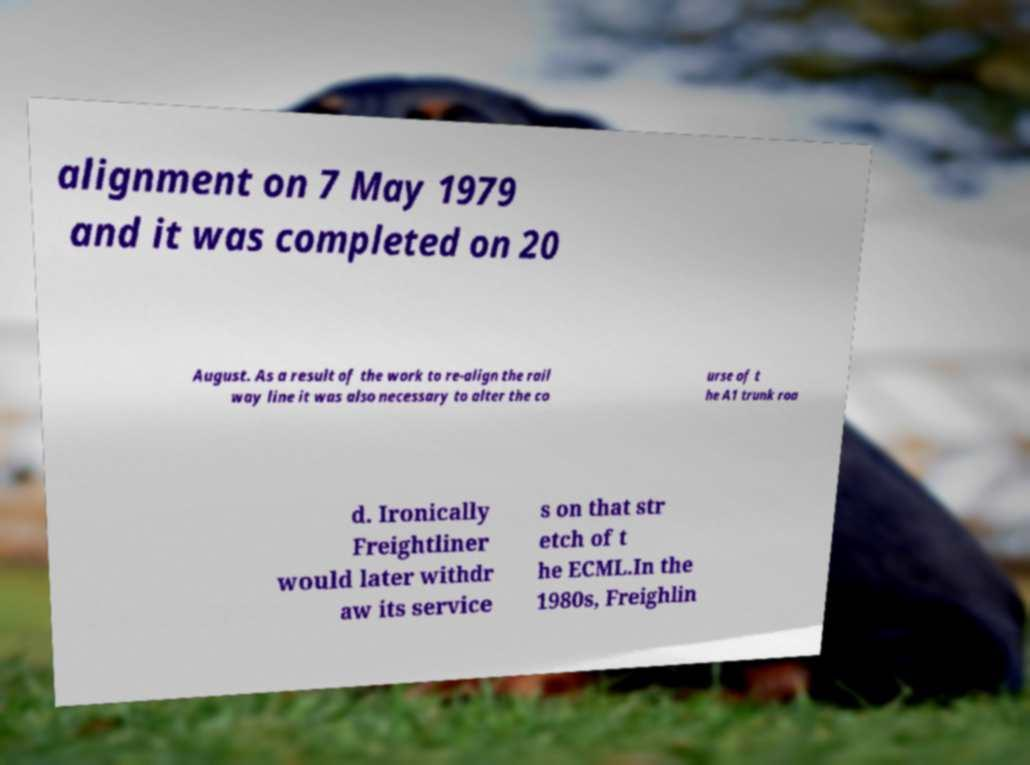What messages or text are displayed in this image? I need them in a readable, typed format. alignment on 7 May 1979 and it was completed on 20 August. As a result of the work to re-align the rail way line it was also necessary to alter the co urse of t he A1 trunk roa d. Ironically Freightliner would later withdr aw its service s on that str etch of t he ECML.In the 1980s, Freighlin 